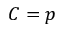Convert formula to latex. <formula><loc_0><loc_0><loc_500><loc_500>C = p</formula> 